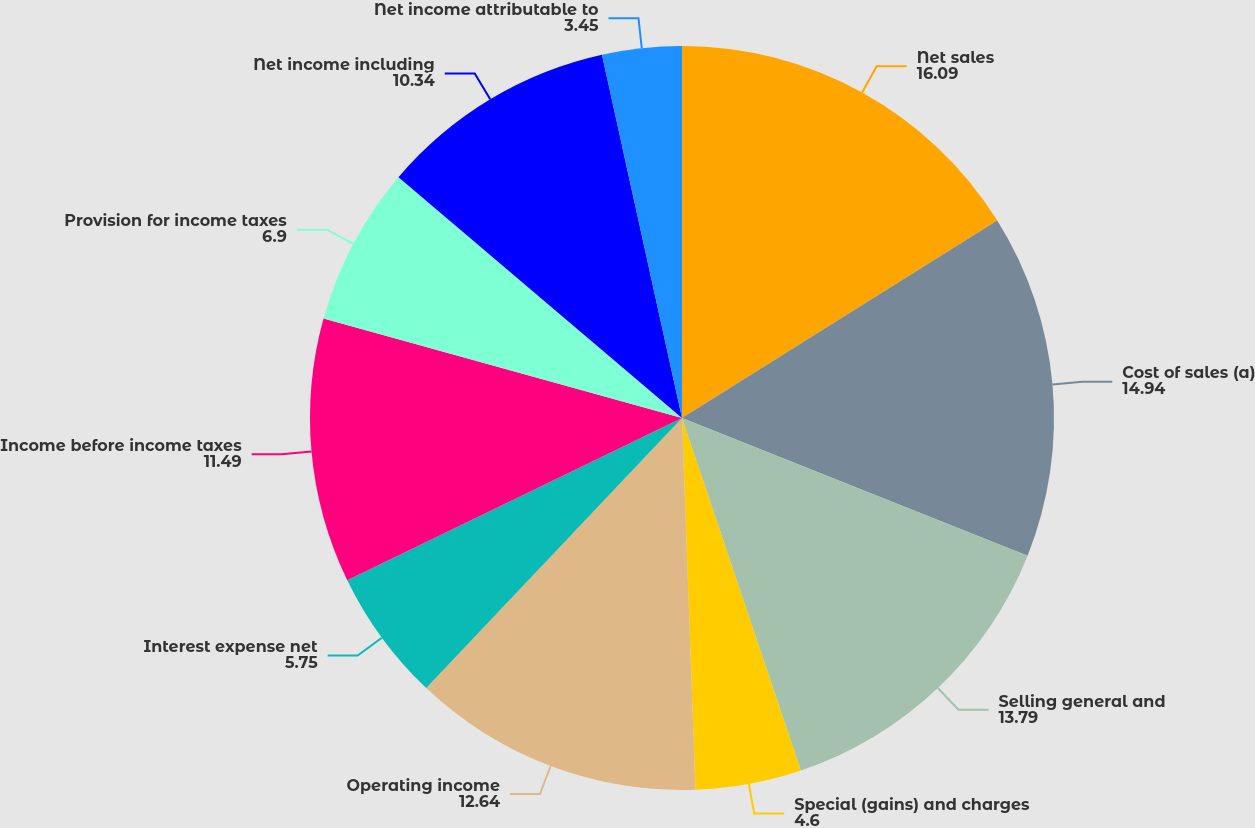Convert chart. <chart><loc_0><loc_0><loc_500><loc_500><pie_chart><fcel>Net sales<fcel>Cost of sales (a)<fcel>Selling general and<fcel>Special (gains) and charges<fcel>Operating income<fcel>Interest expense net<fcel>Income before income taxes<fcel>Provision for income taxes<fcel>Net income including<fcel>Net income attributable to<nl><fcel>16.09%<fcel>14.94%<fcel>13.79%<fcel>4.6%<fcel>12.64%<fcel>5.75%<fcel>11.49%<fcel>6.9%<fcel>10.34%<fcel>3.45%<nl></chart> 